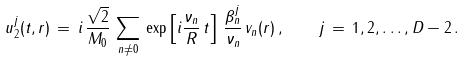<formula> <loc_0><loc_0><loc_500><loc_500>u _ { 2 } ^ { j } ( t , r ) \, = \, i \, \frac { \sqrt { 2 } } { M _ { 0 } } \, \sum _ { n \not = 0 } \, \exp \left [ i \frac { \nu _ { n } } { R } \, t \right ] \, \frac { \beta _ { n } ^ { j } } { \nu _ { n } } \, v _ { n } ( r ) \, { , } \quad j \, = \, 1 , 2 , \dots , D - 2 \, { . }</formula> 